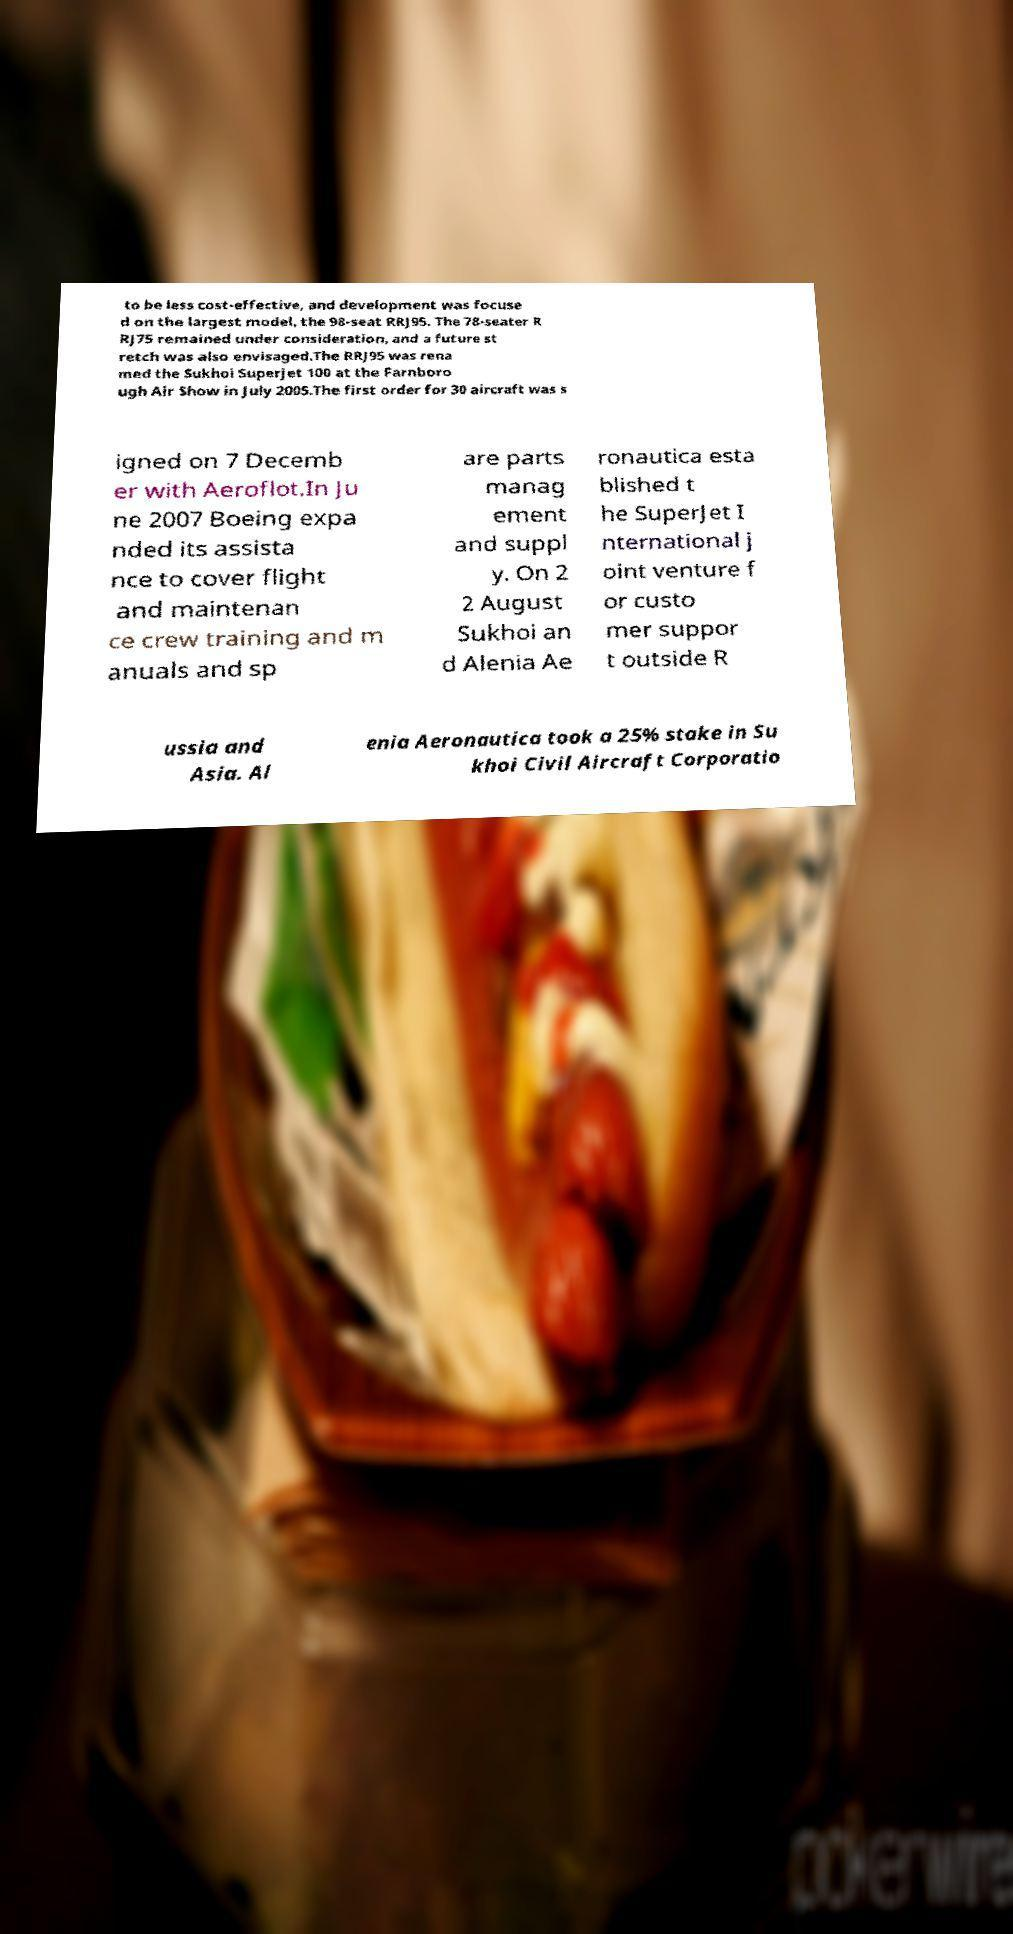I need the written content from this picture converted into text. Can you do that? to be less cost-effective, and development was focuse d on the largest model, the 98-seat RRJ95. The 78-seater R RJ75 remained under consideration, and a future st retch was also envisaged.The RRJ95 was rena med the Sukhoi Superjet 100 at the Farnboro ugh Air Show in July 2005.The first order for 30 aircraft was s igned on 7 Decemb er with Aeroflot.In Ju ne 2007 Boeing expa nded its assista nce to cover flight and maintenan ce crew training and m anuals and sp are parts manag ement and suppl y. On 2 2 August Sukhoi an d Alenia Ae ronautica esta blished t he SuperJet I nternational j oint venture f or custo mer suppor t outside R ussia and Asia. Al enia Aeronautica took a 25% stake in Su khoi Civil Aircraft Corporatio 